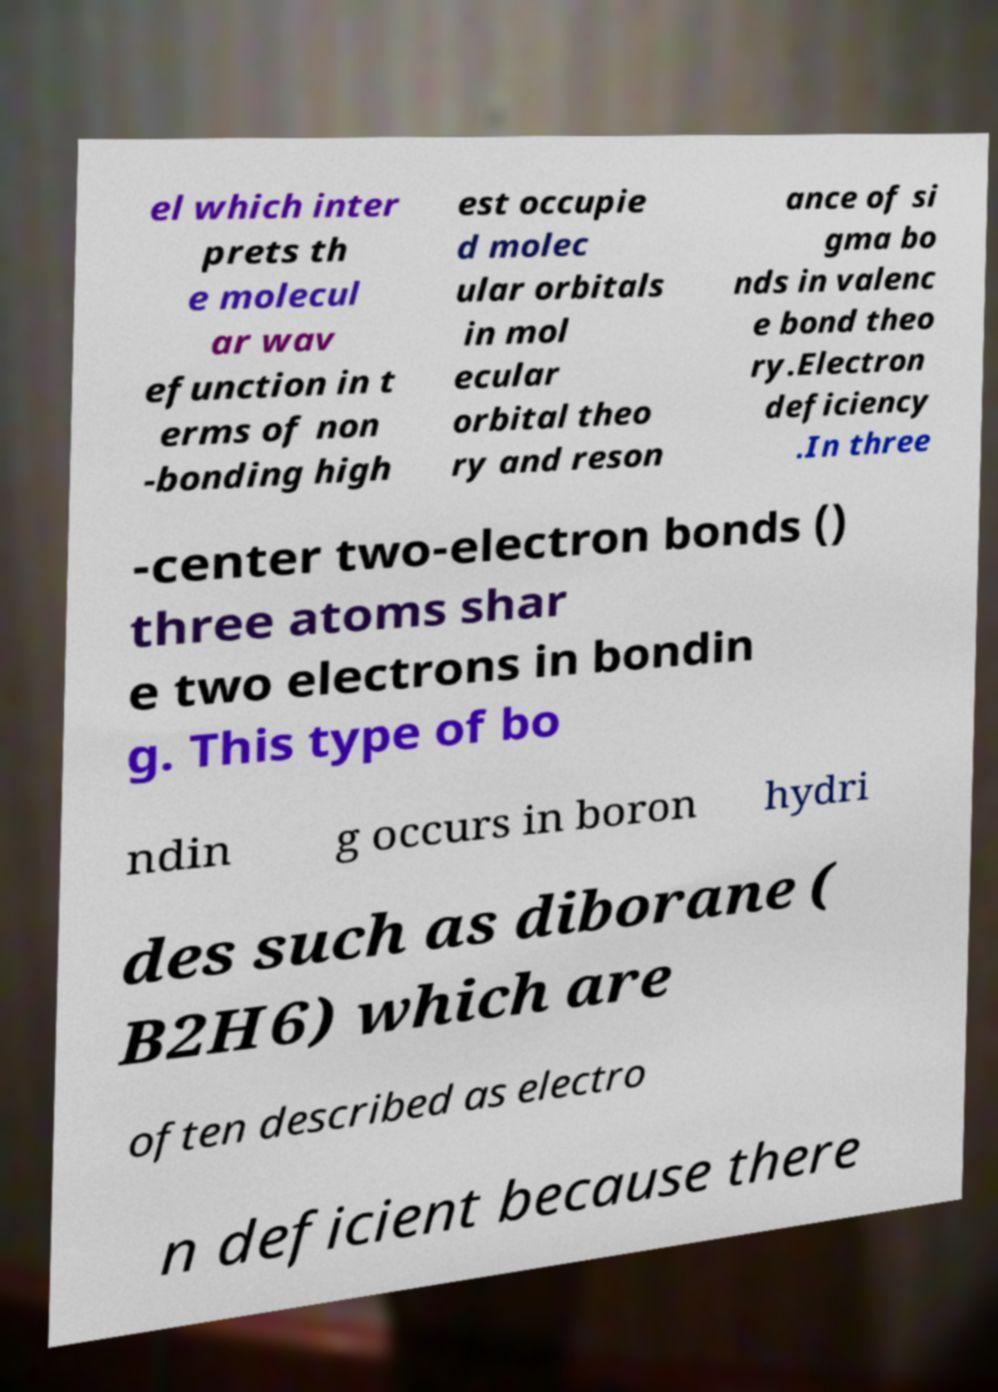Can you read and provide the text displayed in the image?This photo seems to have some interesting text. Can you extract and type it out for me? el which inter prets th e molecul ar wav efunction in t erms of non -bonding high est occupie d molec ular orbitals in mol ecular orbital theo ry and reson ance of si gma bo nds in valenc e bond theo ry.Electron deficiency .In three -center two-electron bonds () three atoms shar e two electrons in bondin g. This type of bo ndin g occurs in boron hydri des such as diborane ( B2H6) which are often described as electro n deficient because there 